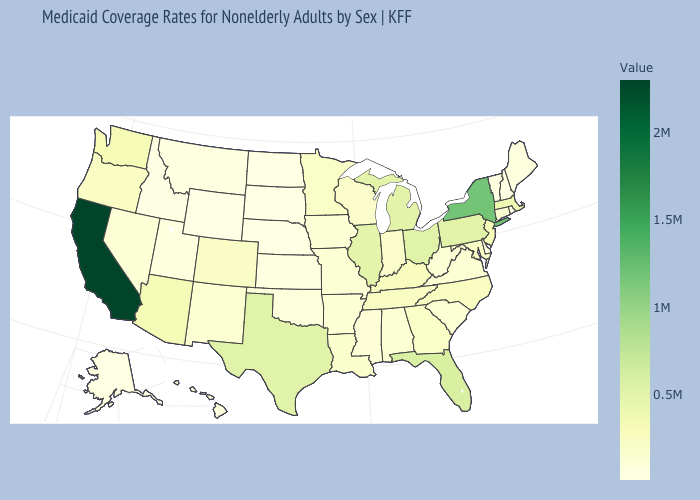Does Michigan have a lower value than New York?
Short answer required. Yes. Is the legend a continuous bar?
Be succinct. Yes. Does the map have missing data?
Quick response, please. No. Does the map have missing data?
Write a very short answer. No. Does California have the highest value in the West?
Answer briefly. Yes. Which states hav the highest value in the West?
Answer briefly. California. 